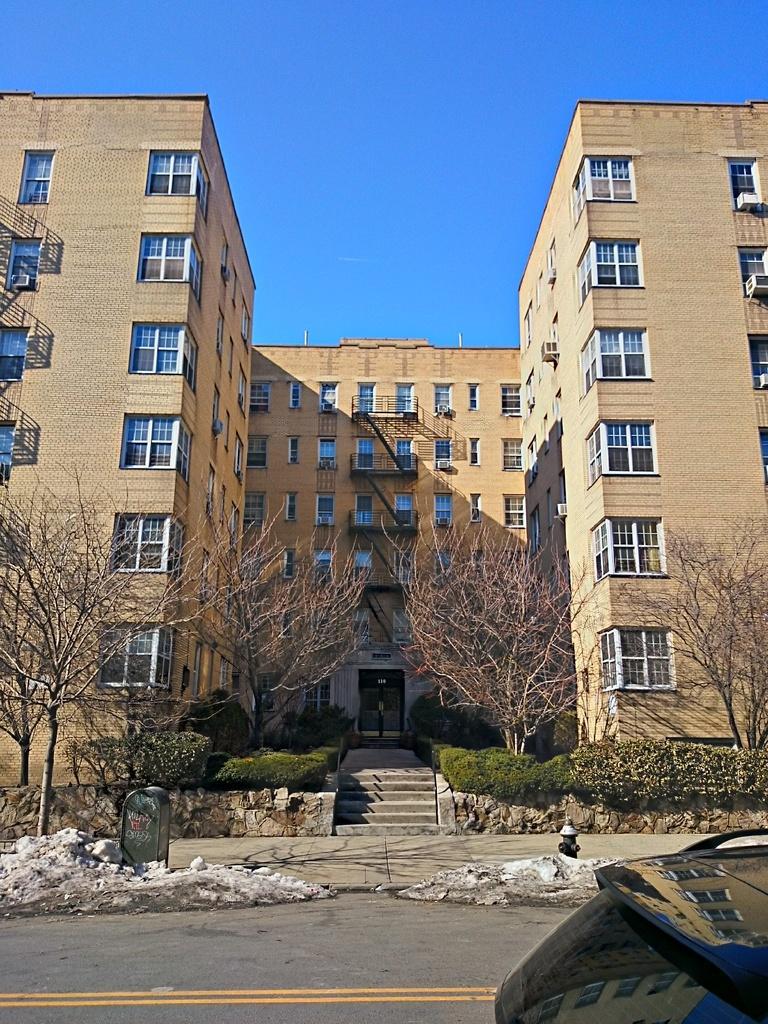Please provide a concise description of this image. In this picture I can see buildings, trees and plants. Here I can see a road on which I can see yellow color line. I can also see a fire hydrant. In the background I can see the sky. 